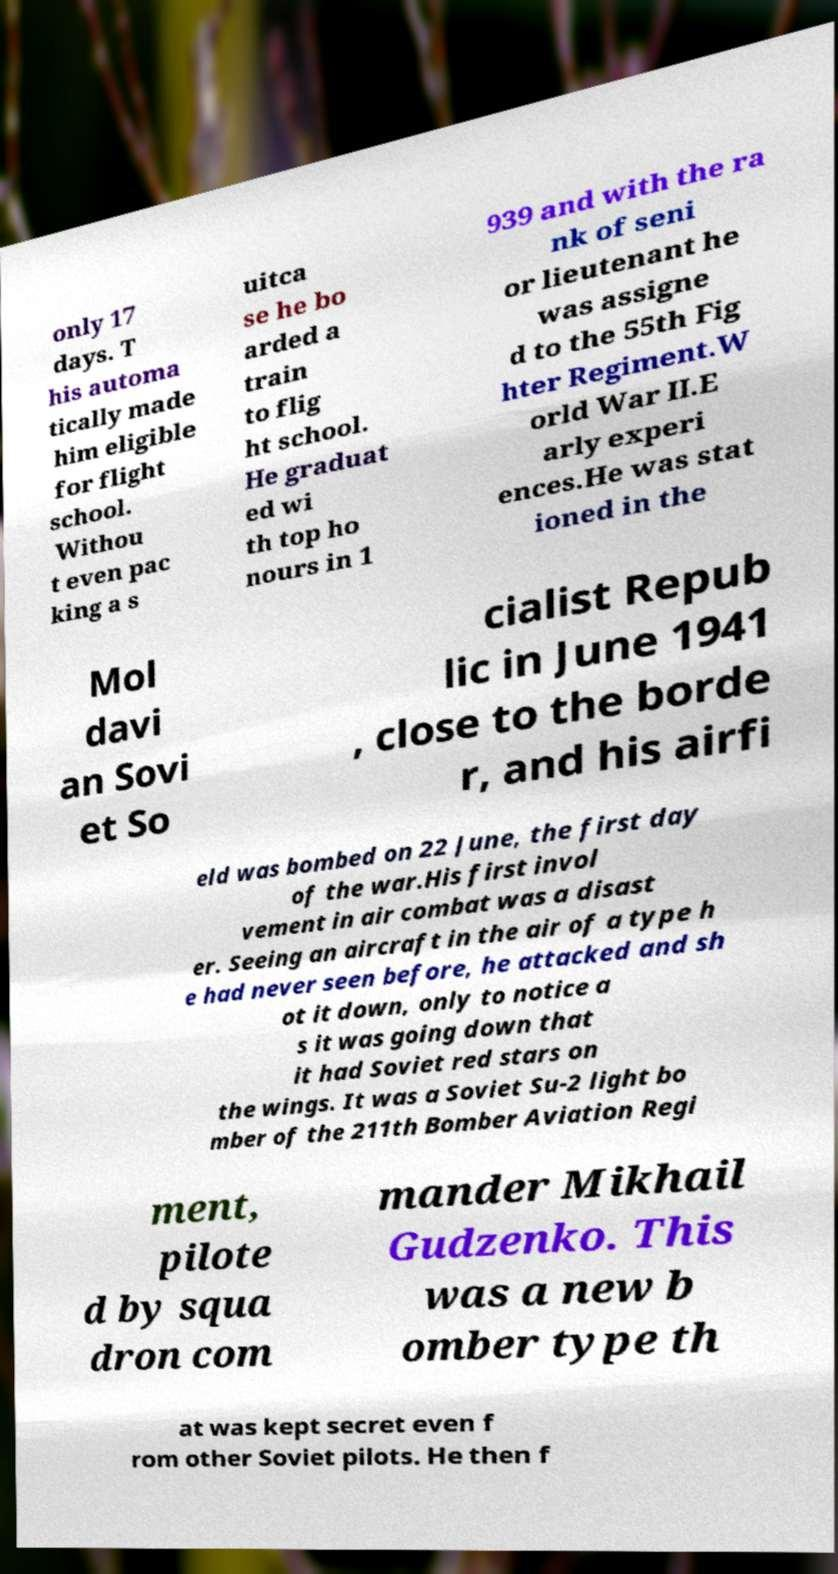For documentation purposes, I need the text within this image transcribed. Could you provide that? only 17 days. T his automa tically made him eligible for flight school. Withou t even pac king a s uitca se he bo arded a train to flig ht school. He graduat ed wi th top ho nours in 1 939 and with the ra nk of seni or lieutenant he was assigne d to the 55th Fig hter Regiment.W orld War II.E arly experi ences.He was stat ioned in the Mol davi an Sovi et So cialist Repub lic in June 1941 , close to the borde r, and his airfi eld was bombed on 22 June, the first day of the war.His first invol vement in air combat was a disast er. Seeing an aircraft in the air of a type h e had never seen before, he attacked and sh ot it down, only to notice a s it was going down that it had Soviet red stars on the wings. It was a Soviet Su-2 light bo mber of the 211th Bomber Aviation Regi ment, pilote d by squa dron com mander Mikhail Gudzenko. This was a new b omber type th at was kept secret even f rom other Soviet pilots. He then f 